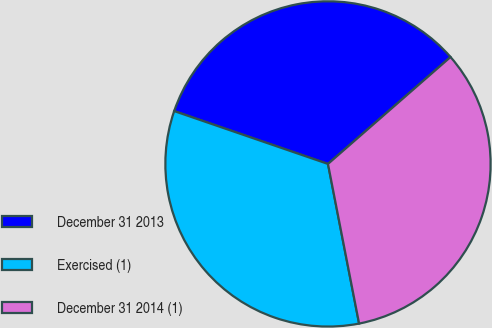Convert chart. <chart><loc_0><loc_0><loc_500><loc_500><pie_chart><fcel>December 31 2013<fcel>Exercised (1)<fcel>December 31 2014 (1)<nl><fcel>33.31%<fcel>33.33%<fcel>33.35%<nl></chart> 